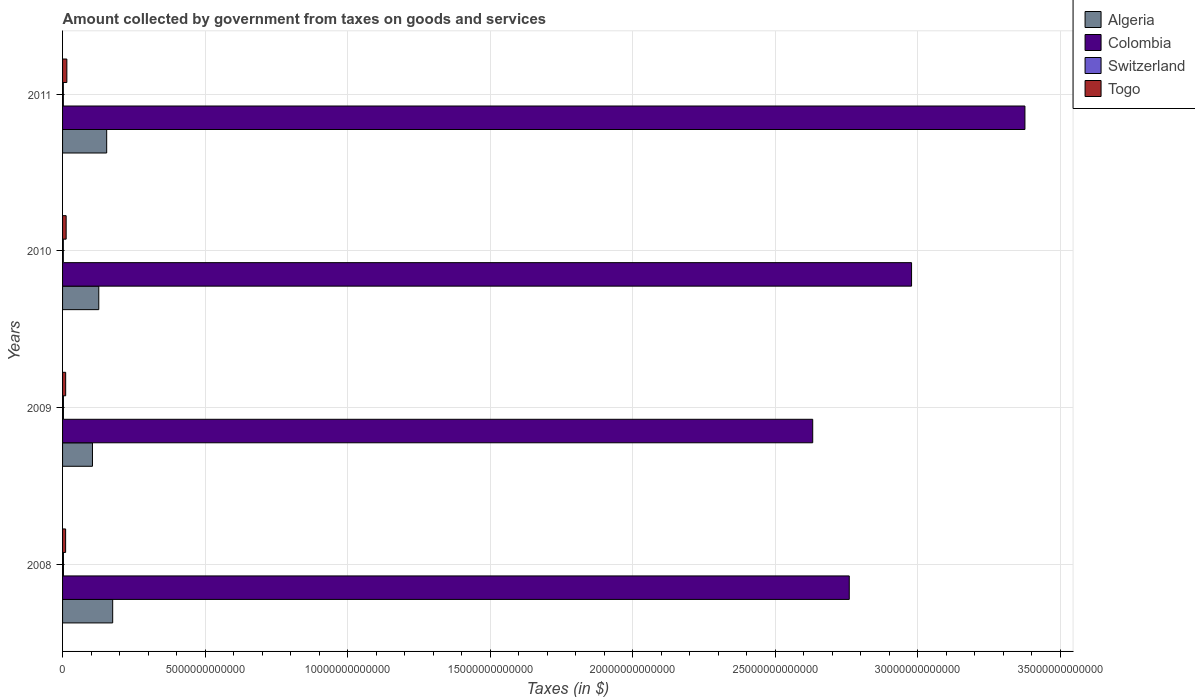How many different coloured bars are there?
Make the answer very short. 4. Are the number of bars per tick equal to the number of legend labels?
Provide a succinct answer. Yes. Are the number of bars on each tick of the Y-axis equal?
Ensure brevity in your answer.  Yes. What is the amount collected by government from taxes on goods and services in Togo in 2009?
Make the answer very short. 1.09e+11. Across all years, what is the maximum amount collected by government from taxes on goods and services in Colombia?
Make the answer very short. 3.38e+13. Across all years, what is the minimum amount collected by government from taxes on goods and services in Togo?
Keep it short and to the point. 1.08e+11. What is the total amount collected by government from taxes on goods and services in Togo in the graph?
Your response must be concise. 4.93e+11. What is the difference between the amount collected by government from taxes on goods and services in Togo in 2008 and that in 2009?
Offer a very short reply. -1.49e+09. What is the difference between the amount collected by government from taxes on goods and services in Togo in 2010 and the amount collected by government from taxes on goods and services in Algeria in 2011?
Your response must be concise. -1.42e+12. What is the average amount collected by government from taxes on goods and services in Togo per year?
Provide a succinct answer. 1.23e+11. In the year 2011, what is the difference between the amount collected by government from taxes on goods and services in Colombia and amount collected by government from taxes on goods and services in Switzerland?
Ensure brevity in your answer.  3.37e+13. In how many years, is the amount collected by government from taxes on goods and services in Switzerland greater than 21000000000000 $?
Give a very brief answer. 0. What is the ratio of the amount collected by government from taxes on goods and services in Algeria in 2008 to that in 2009?
Give a very brief answer. 1.68. What is the difference between the highest and the second highest amount collected by government from taxes on goods and services in Algeria?
Offer a terse response. 2.10e+11. What is the difference between the highest and the lowest amount collected by government from taxes on goods and services in Colombia?
Your response must be concise. 7.44e+12. Is the sum of the amount collected by government from taxes on goods and services in Algeria in 2008 and 2010 greater than the maximum amount collected by government from taxes on goods and services in Colombia across all years?
Provide a short and direct response. No. What does the 4th bar from the top in 2009 represents?
Provide a short and direct response. Algeria. What does the 3rd bar from the bottom in 2008 represents?
Give a very brief answer. Switzerland. Is it the case that in every year, the sum of the amount collected by government from taxes on goods and services in Algeria and amount collected by government from taxes on goods and services in Colombia is greater than the amount collected by government from taxes on goods and services in Togo?
Your answer should be very brief. Yes. How many bars are there?
Provide a succinct answer. 16. Are all the bars in the graph horizontal?
Give a very brief answer. Yes. What is the difference between two consecutive major ticks on the X-axis?
Provide a succinct answer. 5.00e+12. Does the graph contain grids?
Keep it short and to the point. Yes. What is the title of the graph?
Ensure brevity in your answer.  Amount collected by government from taxes on goods and services. Does "Iraq" appear as one of the legend labels in the graph?
Ensure brevity in your answer.  No. What is the label or title of the X-axis?
Your response must be concise. Taxes (in $). What is the label or title of the Y-axis?
Provide a short and direct response. Years. What is the Taxes (in $) in Algeria in 2008?
Provide a succinct answer. 1.76e+12. What is the Taxes (in $) of Colombia in 2008?
Provide a succinct answer. 2.76e+13. What is the Taxes (in $) in Switzerland in 2008?
Your response must be concise. 3.13e+1. What is the Taxes (in $) of Togo in 2008?
Your answer should be very brief. 1.08e+11. What is the Taxes (in $) of Algeria in 2009?
Make the answer very short. 1.05e+12. What is the Taxes (in $) in Colombia in 2009?
Give a very brief answer. 2.63e+13. What is the Taxes (in $) of Switzerland in 2009?
Offer a terse response. 3.04e+1. What is the Taxes (in $) in Togo in 2009?
Offer a terse response. 1.09e+11. What is the Taxes (in $) in Algeria in 2010?
Make the answer very short. 1.27e+12. What is the Taxes (in $) of Colombia in 2010?
Make the answer very short. 2.98e+13. What is the Taxes (in $) in Switzerland in 2010?
Ensure brevity in your answer.  2.69e+1. What is the Taxes (in $) in Togo in 2010?
Ensure brevity in your answer.  1.26e+11. What is the Taxes (in $) of Algeria in 2011?
Provide a short and direct response. 1.55e+12. What is the Taxes (in $) in Colombia in 2011?
Your response must be concise. 3.38e+13. What is the Taxes (in $) of Switzerland in 2011?
Provide a succinct answer. 2.75e+1. What is the Taxes (in $) in Togo in 2011?
Offer a very short reply. 1.50e+11. Across all years, what is the maximum Taxes (in $) in Algeria?
Offer a very short reply. 1.76e+12. Across all years, what is the maximum Taxes (in $) in Colombia?
Your response must be concise. 3.38e+13. Across all years, what is the maximum Taxes (in $) of Switzerland?
Provide a succinct answer. 3.13e+1. Across all years, what is the maximum Taxes (in $) of Togo?
Provide a short and direct response. 1.50e+11. Across all years, what is the minimum Taxes (in $) in Algeria?
Provide a short and direct response. 1.05e+12. Across all years, what is the minimum Taxes (in $) in Colombia?
Make the answer very short. 2.63e+13. Across all years, what is the minimum Taxes (in $) of Switzerland?
Keep it short and to the point. 2.69e+1. Across all years, what is the minimum Taxes (in $) of Togo?
Ensure brevity in your answer.  1.08e+11. What is the total Taxes (in $) of Algeria in the graph?
Ensure brevity in your answer.  5.62e+12. What is the total Taxes (in $) of Colombia in the graph?
Give a very brief answer. 1.17e+14. What is the total Taxes (in $) in Switzerland in the graph?
Ensure brevity in your answer.  1.16e+11. What is the total Taxes (in $) of Togo in the graph?
Provide a succinct answer. 4.93e+11. What is the difference between the Taxes (in $) in Algeria in 2008 and that in 2009?
Your response must be concise. 7.09e+11. What is the difference between the Taxes (in $) in Colombia in 2008 and that in 2009?
Your answer should be very brief. 1.28e+12. What is the difference between the Taxes (in $) in Switzerland in 2008 and that in 2009?
Make the answer very short. 9.00e+08. What is the difference between the Taxes (in $) in Togo in 2008 and that in 2009?
Keep it short and to the point. -1.49e+09. What is the difference between the Taxes (in $) in Algeria in 2008 and that in 2010?
Offer a very short reply. 4.88e+11. What is the difference between the Taxes (in $) of Colombia in 2008 and that in 2010?
Offer a very short reply. -2.18e+12. What is the difference between the Taxes (in $) in Switzerland in 2008 and that in 2010?
Give a very brief answer. 4.39e+09. What is the difference between the Taxes (in $) of Togo in 2008 and that in 2010?
Provide a succinct answer. -1.83e+1. What is the difference between the Taxes (in $) in Algeria in 2008 and that in 2011?
Your answer should be very brief. 2.10e+11. What is the difference between the Taxes (in $) in Colombia in 2008 and that in 2011?
Keep it short and to the point. -6.16e+12. What is the difference between the Taxes (in $) in Switzerland in 2008 and that in 2011?
Offer a very short reply. 3.83e+09. What is the difference between the Taxes (in $) of Togo in 2008 and that in 2011?
Make the answer very short. -4.29e+1. What is the difference between the Taxes (in $) of Algeria in 2009 and that in 2010?
Ensure brevity in your answer.  -2.21e+11. What is the difference between the Taxes (in $) of Colombia in 2009 and that in 2010?
Make the answer very short. -3.47e+12. What is the difference between the Taxes (in $) in Switzerland in 2009 and that in 2010?
Make the answer very short. 3.49e+09. What is the difference between the Taxes (in $) in Togo in 2009 and that in 2010?
Offer a very short reply. -1.68e+1. What is the difference between the Taxes (in $) in Algeria in 2009 and that in 2011?
Your response must be concise. -4.99e+11. What is the difference between the Taxes (in $) in Colombia in 2009 and that in 2011?
Your answer should be very brief. -7.44e+12. What is the difference between the Taxes (in $) in Switzerland in 2009 and that in 2011?
Your answer should be compact. 2.93e+09. What is the difference between the Taxes (in $) in Togo in 2009 and that in 2011?
Provide a succinct answer. -4.14e+1. What is the difference between the Taxes (in $) in Algeria in 2010 and that in 2011?
Ensure brevity in your answer.  -2.78e+11. What is the difference between the Taxes (in $) of Colombia in 2010 and that in 2011?
Provide a short and direct response. -3.98e+12. What is the difference between the Taxes (in $) in Switzerland in 2010 and that in 2011?
Ensure brevity in your answer.  -5.66e+08. What is the difference between the Taxes (in $) of Togo in 2010 and that in 2011?
Provide a succinct answer. -2.46e+1. What is the difference between the Taxes (in $) of Algeria in 2008 and the Taxes (in $) of Colombia in 2009?
Make the answer very short. -2.46e+13. What is the difference between the Taxes (in $) of Algeria in 2008 and the Taxes (in $) of Switzerland in 2009?
Make the answer very short. 1.73e+12. What is the difference between the Taxes (in $) of Algeria in 2008 and the Taxes (in $) of Togo in 2009?
Ensure brevity in your answer.  1.65e+12. What is the difference between the Taxes (in $) of Colombia in 2008 and the Taxes (in $) of Switzerland in 2009?
Provide a short and direct response. 2.76e+13. What is the difference between the Taxes (in $) in Colombia in 2008 and the Taxes (in $) in Togo in 2009?
Provide a short and direct response. 2.75e+13. What is the difference between the Taxes (in $) in Switzerland in 2008 and the Taxes (in $) in Togo in 2009?
Your response must be concise. -7.77e+1. What is the difference between the Taxes (in $) of Algeria in 2008 and the Taxes (in $) of Colombia in 2010?
Your answer should be very brief. -2.80e+13. What is the difference between the Taxes (in $) in Algeria in 2008 and the Taxes (in $) in Switzerland in 2010?
Give a very brief answer. 1.73e+12. What is the difference between the Taxes (in $) of Algeria in 2008 and the Taxes (in $) of Togo in 2010?
Keep it short and to the point. 1.63e+12. What is the difference between the Taxes (in $) of Colombia in 2008 and the Taxes (in $) of Switzerland in 2010?
Your answer should be compact. 2.76e+13. What is the difference between the Taxes (in $) of Colombia in 2008 and the Taxes (in $) of Togo in 2010?
Keep it short and to the point. 2.75e+13. What is the difference between the Taxes (in $) in Switzerland in 2008 and the Taxes (in $) in Togo in 2010?
Your response must be concise. -9.45e+1. What is the difference between the Taxes (in $) in Algeria in 2008 and the Taxes (in $) in Colombia in 2011?
Your answer should be compact. -3.20e+13. What is the difference between the Taxes (in $) in Algeria in 2008 and the Taxes (in $) in Switzerland in 2011?
Your answer should be very brief. 1.73e+12. What is the difference between the Taxes (in $) of Algeria in 2008 and the Taxes (in $) of Togo in 2011?
Give a very brief answer. 1.61e+12. What is the difference between the Taxes (in $) in Colombia in 2008 and the Taxes (in $) in Switzerland in 2011?
Ensure brevity in your answer.  2.76e+13. What is the difference between the Taxes (in $) in Colombia in 2008 and the Taxes (in $) in Togo in 2011?
Offer a very short reply. 2.74e+13. What is the difference between the Taxes (in $) of Switzerland in 2008 and the Taxes (in $) of Togo in 2011?
Your answer should be compact. -1.19e+11. What is the difference between the Taxes (in $) in Algeria in 2009 and the Taxes (in $) in Colombia in 2010?
Provide a short and direct response. -2.87e+13. What is the difference between the Taxes (in $) of Algeria in 2009 and the Taxes (in $) of Switzerland in 2010?
Ensure brevity in your answer.  1.02e+12. What is the difference between the Taxes (in $) in Algeria in 2009 and the Taxes (in $) in Togo in 2010?
Your answer should be very brief. 9.23e+11. What is the difference between the Taxes (in $) in Colombia in 2009 and the Taxes (in $) in Switzerland in 2010?
Offer a very short reply. 2.63e+13. What is the difference between the Taxes (in $) of Colombia in 2009 and the Taxes (in $) of Togo in 2010?
Offer a terse response. 2.62e+13. What is the difference between the Taxes (in $) in Switzerland in 2009 and the Taxes (in $) in Togo in 2010?
Provide a succinct answer. -9.54e+1. What is the difference between the Taxes (in $) in Algeria in 2009 and the Taxes (in $) in Colombia in 2011?
Make the answer very short. -3.27e+13. What is the difference between the Taxes (in $) of Algeria in 2009 and the Taxes (in $) of Switzerland in 2011?
Give a very brief answer. 1.02e+12. What is the difference between the Taxes (in $) in Algeria in 2009 and the Taxes (in $) in Togo in 2011?
Provide a short and direct response. 8.99e+11. What is the difference between the Taxes (in $) of Colombia in 2009 and the Taxes (in $) of Switzerland in 2011?
Your response must be concise. 2.63e+13. What is the difference between the Taxes (in $) of Colombia in 2009 and the Taxes (in $) of Togo in 2011?
Keep it short and to the point. 2.62e+13. What is the difference between the Taxes (in $) of Switzerland in 2009 and the Taxes (in $) of Togo in 2011?
Make the answer very short. -1.20e+11. What is the difference between the Taxes (in $) in Algeria in 2010 and the Taxes (in $) in Colombia in 2011?
Your answer should be very brief. -3.25e+13. What is the difference between the Taxes (in $) in Algeria in 2010 and the Taxes (in $) in Switzerland in 2011?
Give a very brief answer. 1.24e+12. What is the difference between the Taxes (in $) of Algeria in 2010 and the Taxes (in $) of Togo in 2011?
Keep it short and to the point. 1.12e+12. What is the difference between the Taxes (in $) in Colombia in 2010 and the Taxes (in $) in Switzerland in 2011?
Provide a succinct answer. 2.97e+13. What is the difference between the Taxes (in $) in Colombia in 2010 and the Taxes (in $) in Togo in 2011?
Your response must be concise. 2.96e+13. What is the difference between the Taxes (in $) in Switzerland in 2010 and the Taxes (in $) in Togo in 2011?
Make the answer very short. -1.24e+11. What is the average Taxes (in $) in Algeria per year?
Your response must be concise. 1.41e+12. What is the average Taxes (in $) of Colombia per year?
Your answer should be compact. 2.94e+13. What is the average Taxes (in $) of Switzerland per year?
Your response must be concise. 2.90e+1. What is the average Taxes (in $) of Togo per year?
Give a very brief answer. 1.23e+11. In the year 2008, what is the difference between the Taxes (in $) of Algeria and Taxes (in $) of Colombia?
Give a very brief answer. -2.58e+13. In the year 2008, what is the difference between the Taxes (in $) of Algeria and Taxes (in $) of Switzerland?
Your response must be concise. 1.73e+12. In the year 2008, what is the difference between the Taxes (in $) in Algeria and Taxes (in $) in Togo?
Keep it short and to the point. 1.65e+12. In the year 2008, what is the difference between the Taxes (in $) in Colombia and Taxes (in $) in Switzerland?
Ensure brevity in your answer.  2.76e+13. In the year 2008, what is the difference between the Taxes (in $) of Colombia and Taxes (in $) of Togo?
Your response must be concise. 2.75e+13. In the year 2008, what is the difference between the Taxes (in $) in Switzerland and Taxes (in $) in Togo?
Keep it short and to the point. -7.62e+1. In the year 2009, what is the difference between the Taxes (in $) of Algeria and Taxes (in $) of Colombia?
Give a very brief answer. -2.53e+13. In the year 2009, what is the difference between the Taxes (in $) of Algeria and Taxes (in $) of Switzerland?
Your answer should be very brief. 1.02e+12. In the year 2009, what is the difference between the Taxes (in $) in Algeria and Taxes (in $) in Togo?
Keep it short and to the point. 9.40e+11. In the year 2009, what is the difference between the Taxes (in $) of Colombia and Taxes (in $) of Switzerland?
Keep it short and to the point. 2.63e+13. In the year 2009, what is the difference between the Taxes (in $) of Colombia and Taxes (in $) of Togo?
Make the answer very short. 2.62e+13. In the year 2009, what is the difference between the Taxes (in $) of Switzerland and Taxes (in $) of Togo?
Offer a terse response. -7.86e+1. In the year 2010, what is the difference between the Taxes (in $) in Algeria and Taxes (in $) in Colombia?
Provide a short and direct response. -2.85e+13. In the year 2010, what is the difference between the Taxes (in $) of Algeria and Taxes (in $) of Switzerland?
Your answer should be very brief. 1.24e+12. In the year 2010, what is the difference between the Taxes (in $) in Algeria and Taxes (in $) in Togo?
Your response must be concise. 1.14e+12. In the year 2010, what is the difference between the Taxes (in $) of Colombia and Taxes (in $) of Switzerland?
Your answer should be compact. 2.98e+13. In the year 2010, what is the difference between the Taxes (in $) in Colombia and Taxes (in $) in Togo?
Provide a succinct answer. 2.97e+13. In the year 2010, what is the difference between the Taxes (in $) in Switzerland and Taxes (in $) in Togo?
Offer a terse response. -9.89e+1. In the year 2011, what is the difference between the Taxes (in $) of Algeria and Taxes (in $) of Colombia?
Give a very brief answer. -3.22e+13. In the year 2011, what is the difference between the Taxes (in $) in Algeria and Taxes (in $) in Switzerland?
Make the answer very short. 1.52e+12. In the year 2011, what is the difference between the Taxes (in $) of Algeria and Taxes (in $) of Togo?
Your answer should be compact. 1.40e+12. In the year 2011, what is the difference between the Taxes (in $) in Colombia and Taxes (in $) in Switzerland?
Keep it short and to the point. 3.37e+13. In the year 2011, what is the difference between the Taxes (in $) of Colombia and Taxes (in $) of Togo?
Keep it short and to the point. 3.36e+13. In the year 2011, what is the difference between the Taxes (in $) in Switzerland and Taxes (in $) in Togo?
Offer a terse response. -1.23e+11. What is the ratio of the Taxes (in $) in Algeria in 2008 to that in 2009?
Your answer should be very brief. 1.68. What is the ratio of the Taxes (in $) of Colombia in 2008 to that in 2009?
Offer a terse response. 1.05. What is the ratio of the Taxes (in $) in Switzerland in 2008 to that in 2009?
Make the answer very short. 1.03. What is the ratio of the Taxes (in $) in Togo in 2008 to that in 2009?
Your answer should be very brief. 0.99. What is the ratio of the Taxes (in $) in Algeria in 2008 to that in 2010?
Your answer should be compact. 1.38. What is the ratio of the Taxes (in $) in Colombia in 2008 to that in 2010?
Keep it short and to the point. 0.93. What is the ratio of the Taxes (in $) of Switzerland in 2008 to that in 2010?
Give a very brief answer. 1.16. What is the ratio of the Taxes (in $) of Togo in 2008 to that in 2010?
Provide a succinct answer. 0.85. What is the ratio of the Taxes (in $) in Algeria in 2008 to that in 2011?
Offer a very short reply. 1.14. What is the ratio of the Taxes (in $) in Colombia in 2008 to that in 2011?
Keep it short and to the point. 0.82. What is the ratio of the Taxes (in $) in Switzerland in 2008 to that in 2011?
Offer a very short reply. 1.14. What is the ratio of the Taxes (in $) in Togo in 2008 to that in 2011?
Keep it short and to the point. 0.71. What is the ratio of the Taxes (in $) of Algeria in 2009 to that in 2010?
Provide a short and direct response. 0.83. What is the ratio of the Taxes (in $) in Colombia in 2009 to that in 2010?
Your answer should be very brief. 0.88. What is the ratio of the Taxes (in $) in Switzerland in 2009 to that in 2010?
Your answer should be very brief. 1.13. What is the ratio of the Taxes (in $) of Togo in 2009 to that in 2010?
Offer a terse response. 0.87. What is the ratio of the Taxes (in $) in Algeria in 2009 to that in 2011?
Give a very brief answer. 0.68. What is the ratio of the Taxes (in $) of Colombia in 2009 to that in 2011?
Give a very brief answer. 0.78. What is the ratio of the Taxes (in $) of Switzerland in 2009 to that in 2011?
Ensure brevity in your answer.  1.11. What is the ratio of the Taxes (in $) of Togo in 2009 to that in 2011?
Your response must be concise. 0.72. What is the ratio of the Taxes (in $) of Algeria in 2010 to that in 2011?
Give a very brief answer. 0.82. What is the ratio of the Taxes (in $) of Colombia in 2010 to that in 2011?
Keep it short and to the point. 0.88. What is the ratio of the Taxes (in $) in Switzerland in 2010 to that in 2011?
Make the answer very short. 0.98. What is the ratio of the Taxes (in $) of Togo in 2010 to that in 2011?
Offer a terse response. 0.84. What is the difference between the highest and the second highest Taxes (in $) in Algeria?
Make the answer very short. 2.10e+11. What is the difference between the highest and the second highest Taxes (in $) in Colombia?
Your response must be concise. 3.98e+12. What is the difference between the highest and the second highest Taxes (in $) of Switzerland?
Give a very brief answer. 9.00e+08. What is the difference between the highest and the second highest Taxes (in $) of Togo?
Ensure brevity in your answer.  2.46e+1. What is the difference between the highest and the lowest Taxes (in $) in Algeria?
Your response must be concise. 7.09e+11. What is the difference between the highest and the lowest Taxes (in $) of Colombia?
Provide a succinct answer. 7.44e+12. What is the difference between the highest and the lowest Taxes (in $) in Switzerland?
Make the answer very short. 4.39e+09. What is the difference between the highest and the lowest Taxes (in $) in Togo?
Your answer should be very brief. 4.29e+1. 